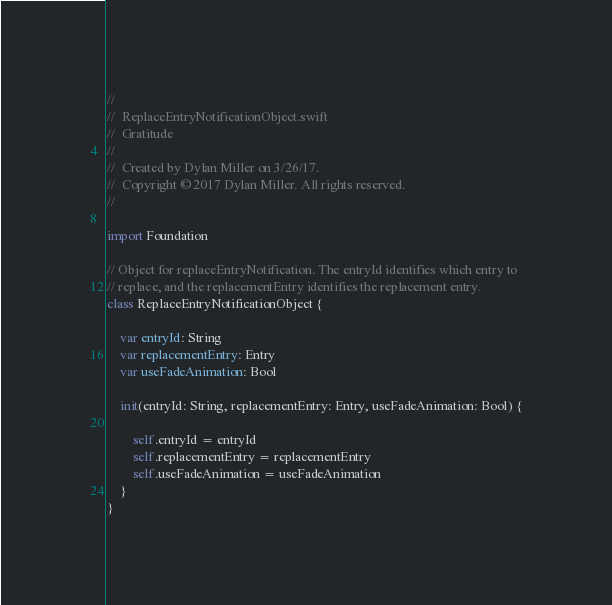Convert code to text. <code><loc_0><loc_0><loc_500><loc_500><_Swift_>//
//  ReplaceEntryNotificationObject.swift
//  Gratitude
//
//  Created by Dylan Miller on 3/26/17.
//  Copyright © 2017 Dylan Miller. All rights reserved.
//

import Foundation

// Object for replaceEntryNotification. The entryId identifies which entry to
// replace, and the replacementEntry identifies the replacement entry.
class ReplaceEntryNotificationObject {
    
    var entryId: String
    var replacementEntry: Entry
    var useFadeAnimation: Bool
    
    init(entryId: String, replacementEntry: Entry, useFadeAnimation: Bool) {
        
        self.entryId = entryId
        self.replacementEntry = replacementEntry
        self.useFadeAnimation = useFadeAnimation
    }
}
</code> 